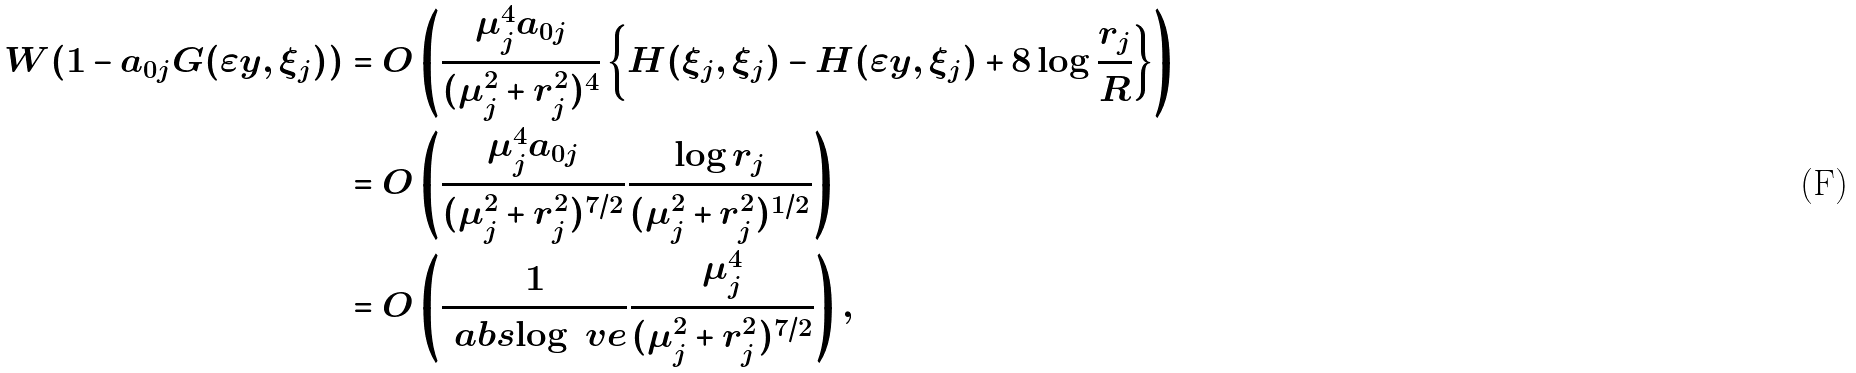Convert formula to latex. <formula><loc_0><loc_0><loc_500><loc_500>W ( 1 - a _ { 0 j } G ( \varepsilon y , \xi _ { j } ) ) & = O \left ( \frac { \mu _ { j } ^ { 4 } a _ { 0 j } } { ( \mu _ { j } ^ { 2 } + r _ { j } ^ { 2 } ) ^ { 4 } } \left \{ H ( \xi _ { j } , \xi _ { j } ) - H ( \varepsilon y , \xi _ { j } ) + 8 \log \frac { r _ { j } } { R } \right \} \right ) \\ & = O \left ( \frac { \mu _ { j } ^ { 4 } a _ { 0 j } } { ( \mu _ { j } ^ { 2 } + r _ { j } ^ { 2 } ) ^ { 7 / 2 } } \frac { \log r _ { j } } { ( \mu _ { j } ^ { 2 } + r _ { j } ^ { 2 } ) ^ { 1 / 2 } } \right ) \\ & = O \left ( \frac { 1 } { \ a b s { \log \ v e } } \frac { \mu _ { j } ^ { 4 } } { ( \mu _ { j } ^ { 2 } + r _ { j } ^ { 2 } ) ^ { 7 / 2 } } \right ) ,</formula> 